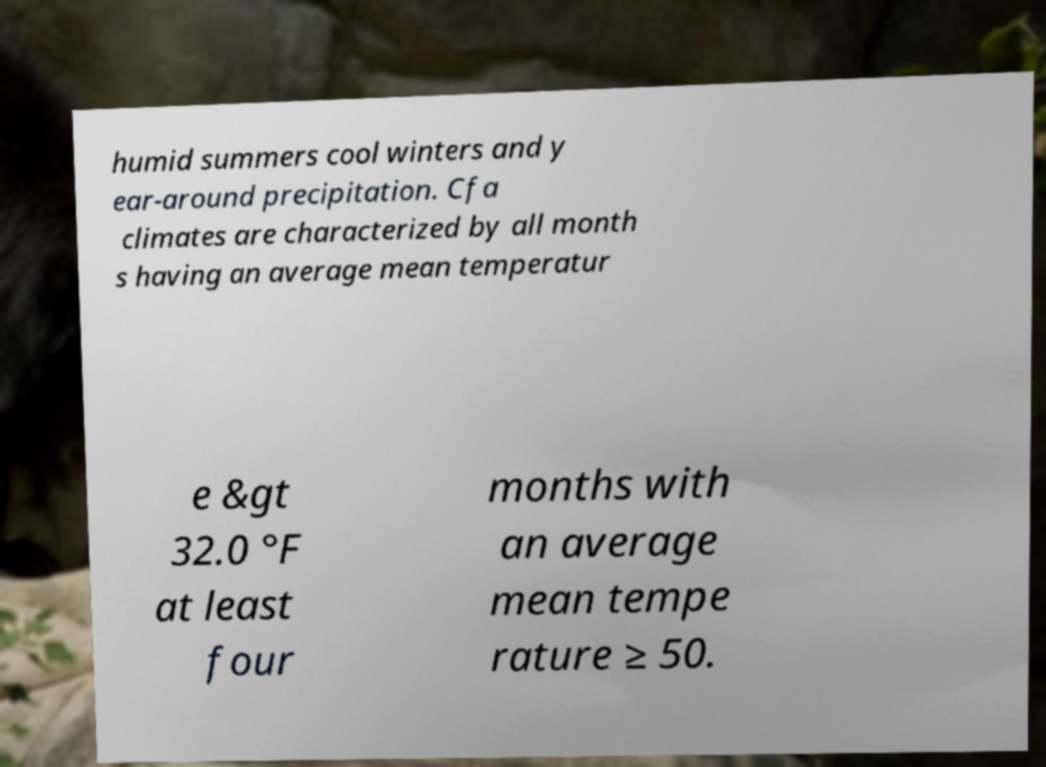Can you accurately transcribe the text from the provided image for me? humid summers cool winters and y ear-around precipitation. Cfa climates are characterized by all month s having an average mean temperatur e &gt 32.0 °F at least four months with an average mean tempe rature ≥ 50. 